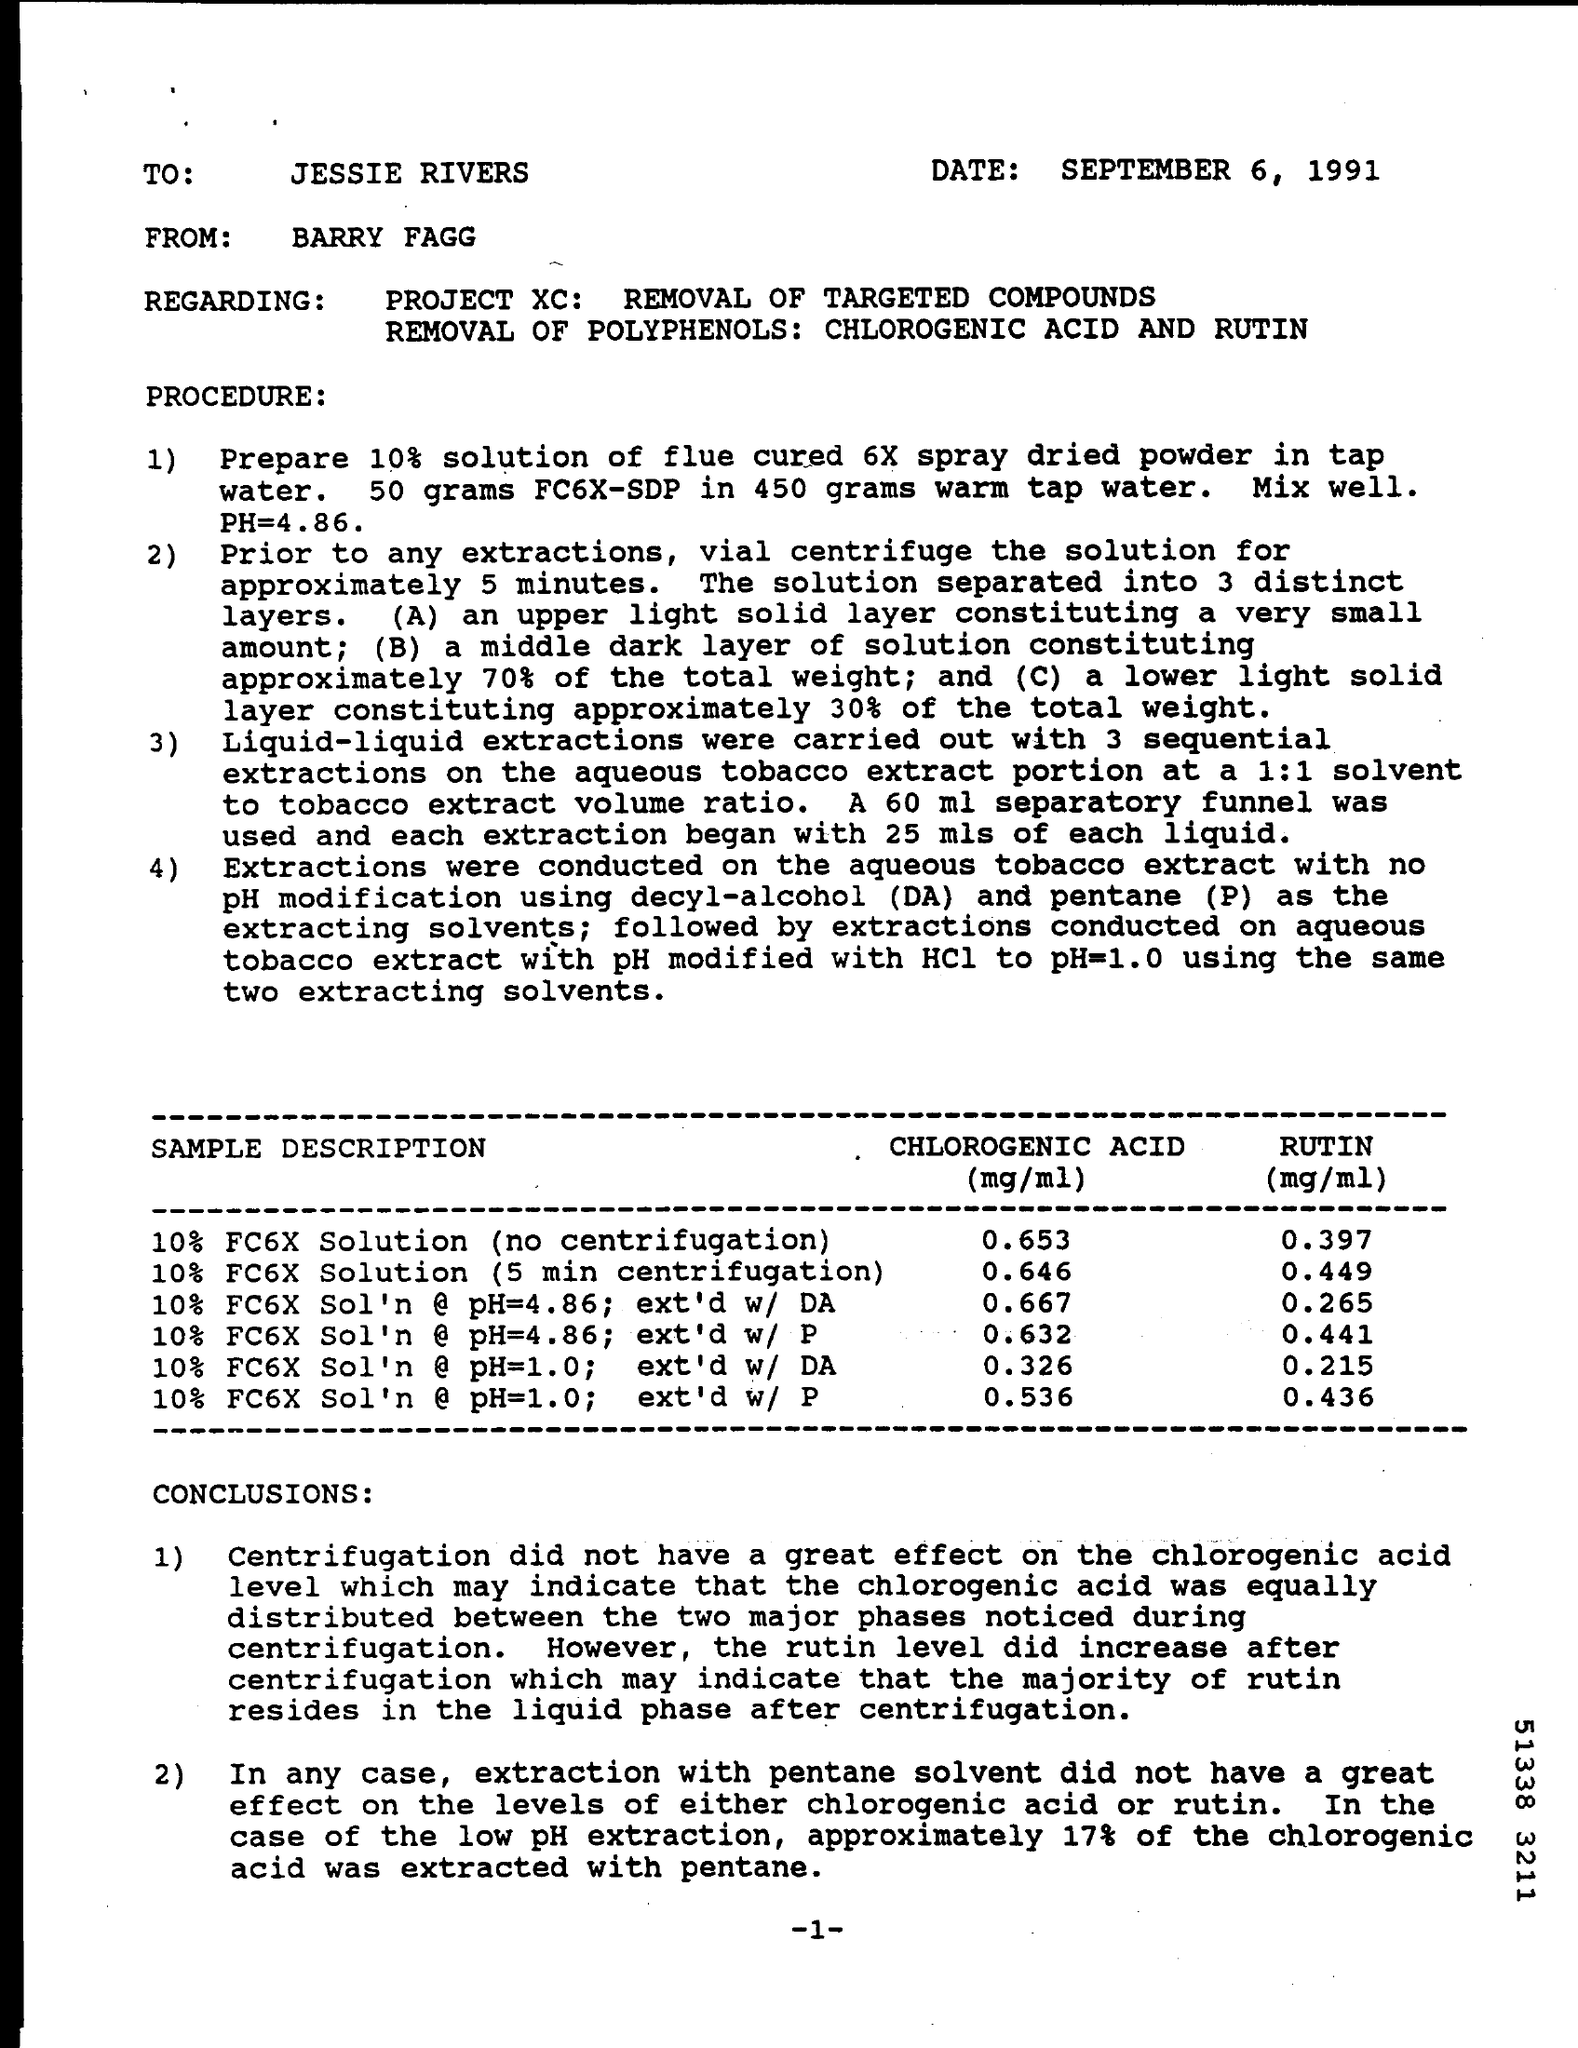To whom this letter was written ?
Offer a very short reply. JESSIE RIVERS. What is the date mentioned in the given letter ?
Offer a terse response. September 6, 1991. 